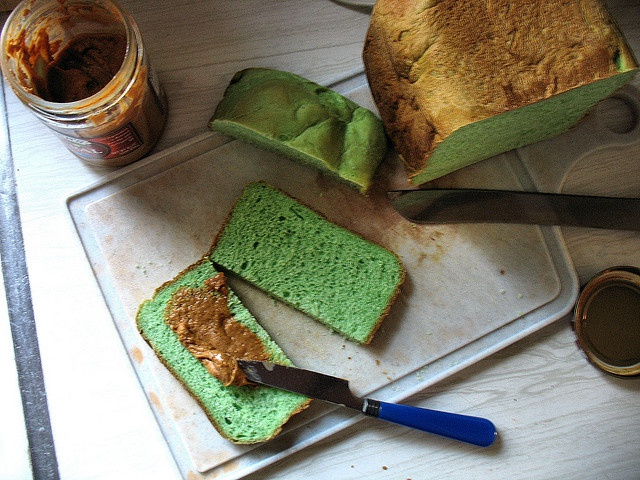Describe the objects in this image and their specific colors. I can see dining table in white, darkgreen, black, darkgray, and gray tones, sandwich in maroon, green, darkgreen, and lightgreen tones, knife in maroon, black, and darkgreen tones, and knife in maroon, black, navy, darkblue, and gray tones in this image. 